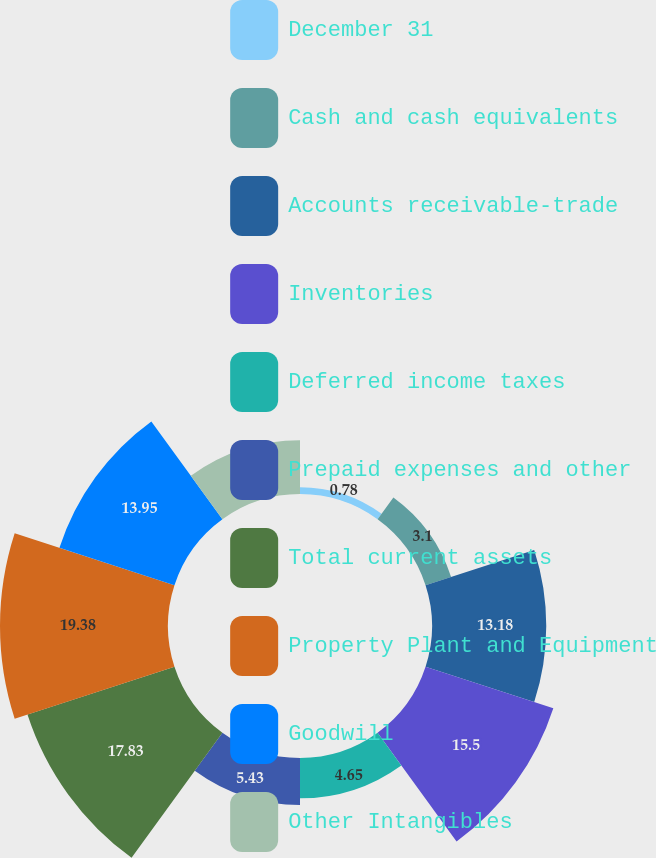Convert chart. <chart><loc_0><loc_0><loc_500><loc_500><pie_chart><fcel>December 31<fcel>Cash and cash equivalents<fcel>Accounts receivable-trade<fcel>Inventories<fcel>Deferred income taxes<fcel>Prepaid expenses and other<fcel>Total current assets<fcel>Property Plant and Equipment<fcel>Goodwill<fcel>Other Intangibles<nl><fcel>0.78%<fcel>3.1%<fcel>13.18%<fcel>15.5%<fcel>4.65%<fcel>5.43%<fcel>17.83%<fcel>19.38%<fcel>13.95%<fcel>6.2%<nl></chart> 